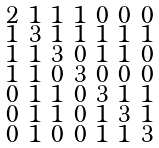<formula> <loc_0><loc_0><loc_500><loc_500>\begin{smallmatrix} 2 & 1 & 1 & 1 & 0 & 0 & 0 \\ 1 & 3 & 1 & 1 & 1 & 1 & 1 \\ 1 & 1 & 3 & 0 & 1 & 1 & 0 \\ 1 & 1 & 0 & 3 & 0 & 0 & 0 \\ 0 & 1 & 1 & 0 & 3 & 1 & 1 \\ 0 & 1 & 1 & 0 & 1 & 3 & 1 \\ 0 & 1 & 0 & 0 & 1 & 1 & 3 \end{smallmatrix}</formula> 